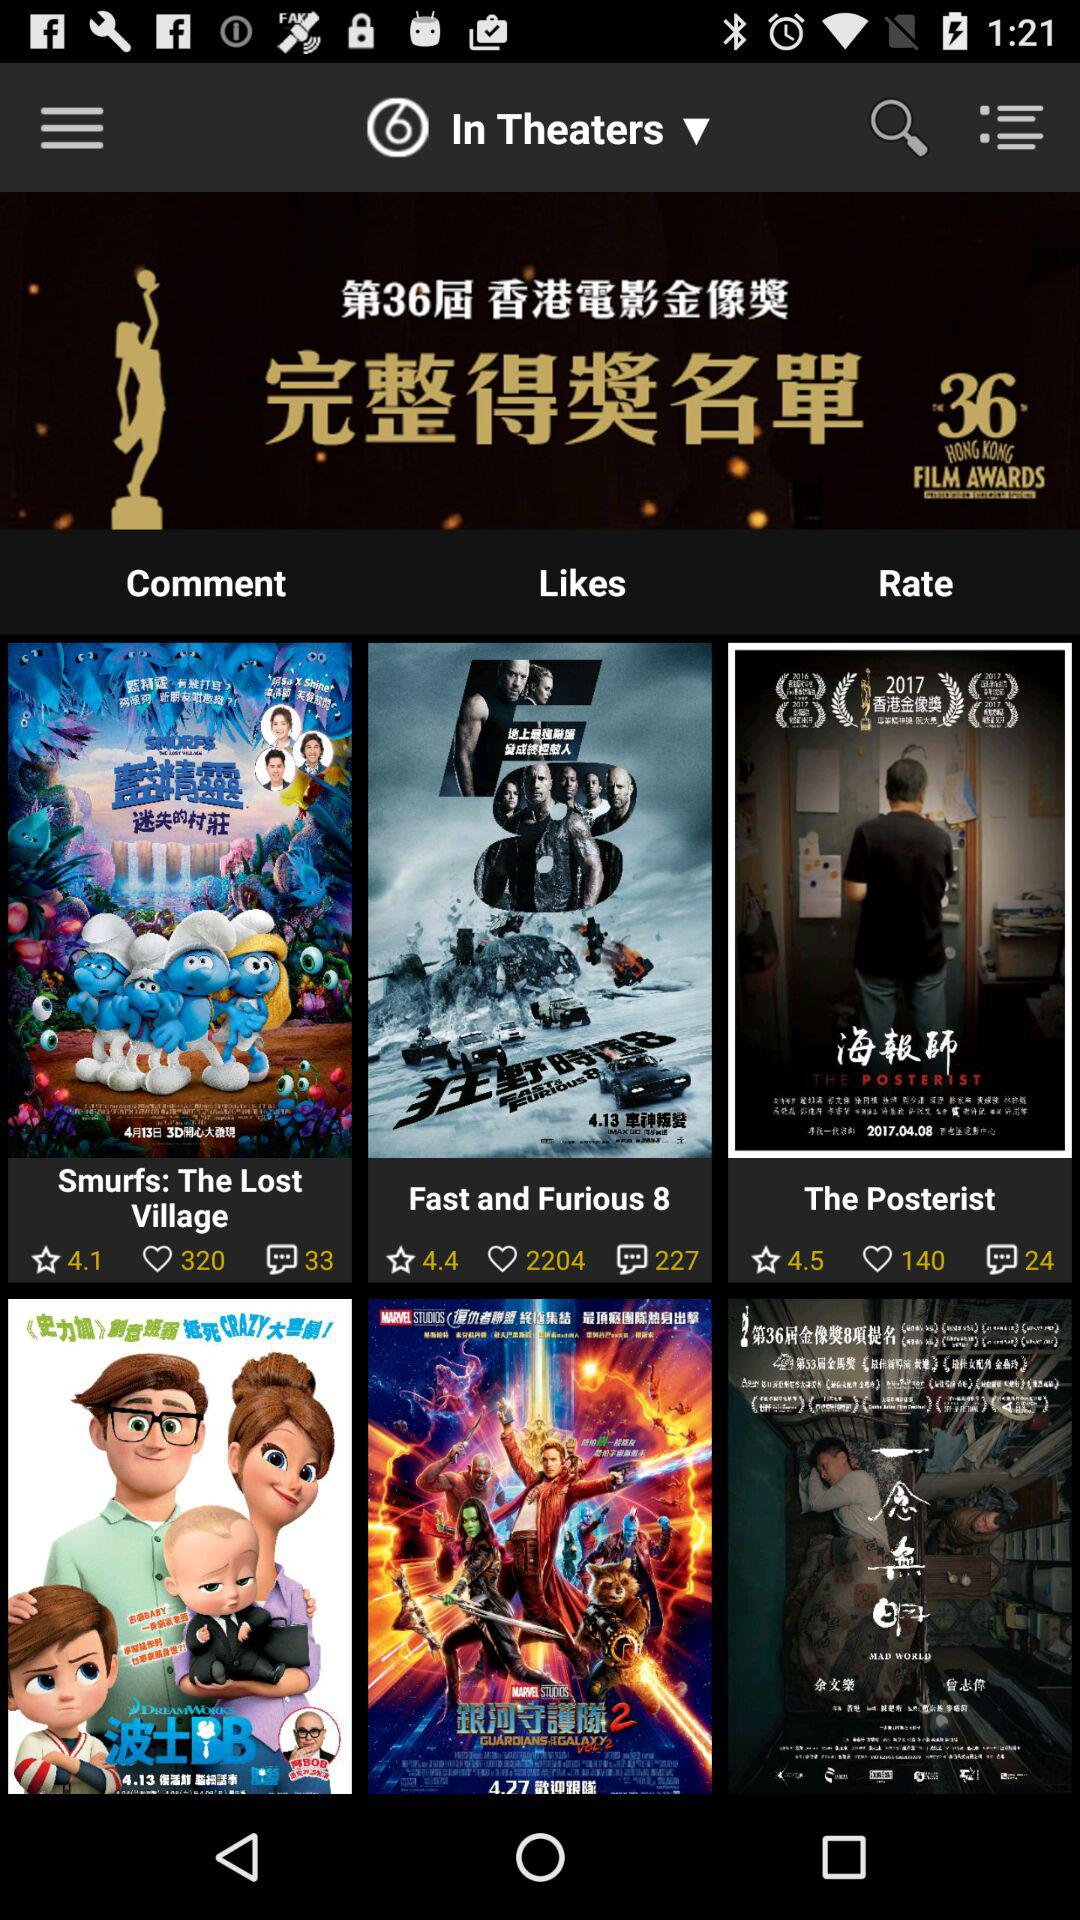How many comments are there for "The Posterist"? There are 24 comments. 